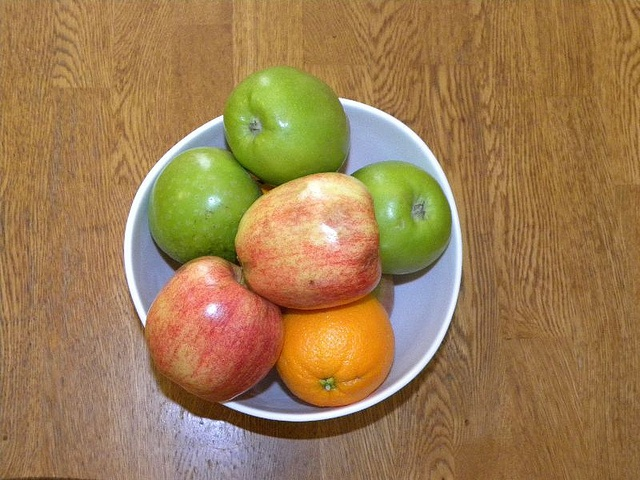Describe the objects in this image and their specific colors. I can see dining table in gray, olive, and tan tones, bowl in tan, olive, darkgray, and brown tones, apple in tan and brown tones, apple in tan, salmon, and brown tones, and apple in tan and olive tones in this image. 